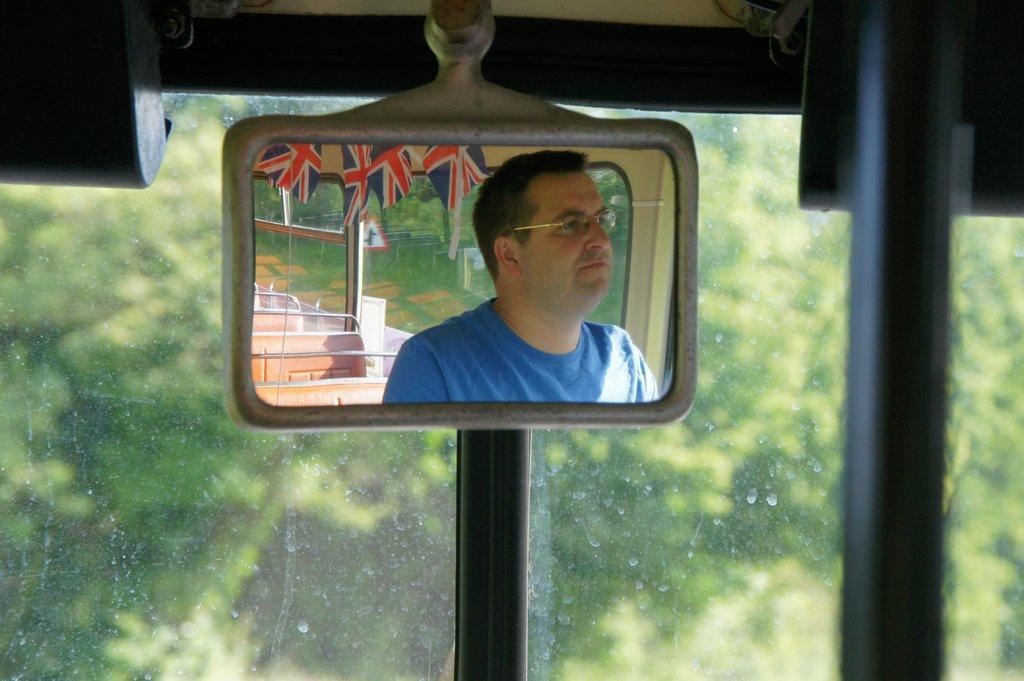Please provide a concise description of this image. In this image I can see the reflection of the person, seats and flags on the mirror. The mirror is inside the vehicle. In the background I can see the glass and few trees. 